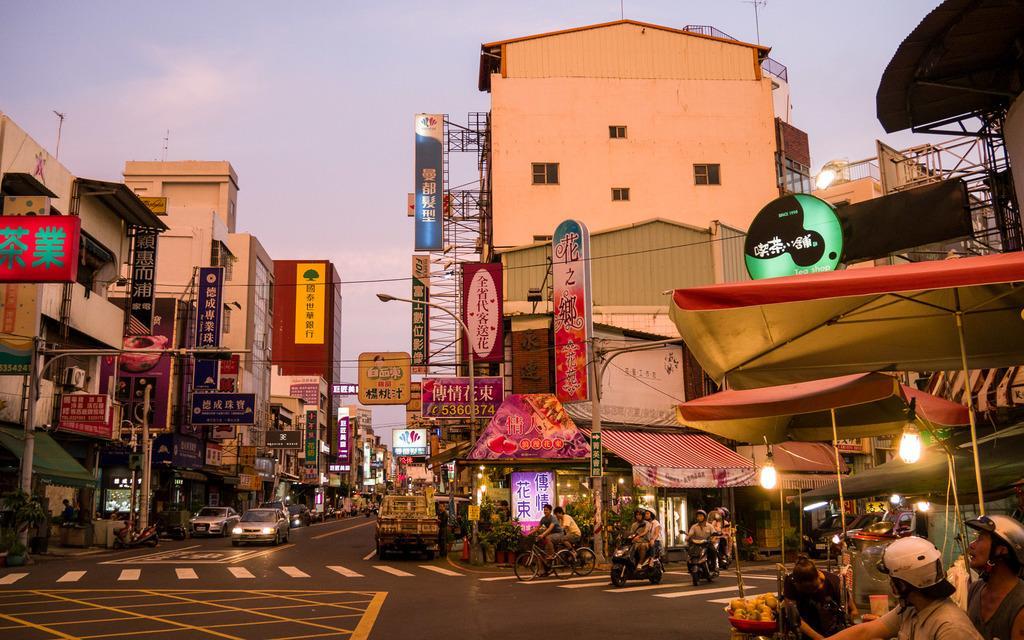Please provide a concise description of this image. In this image we can see buildings with windows, light poles, vehicles, people, sheds, boards with some text and we can also see the sky. 